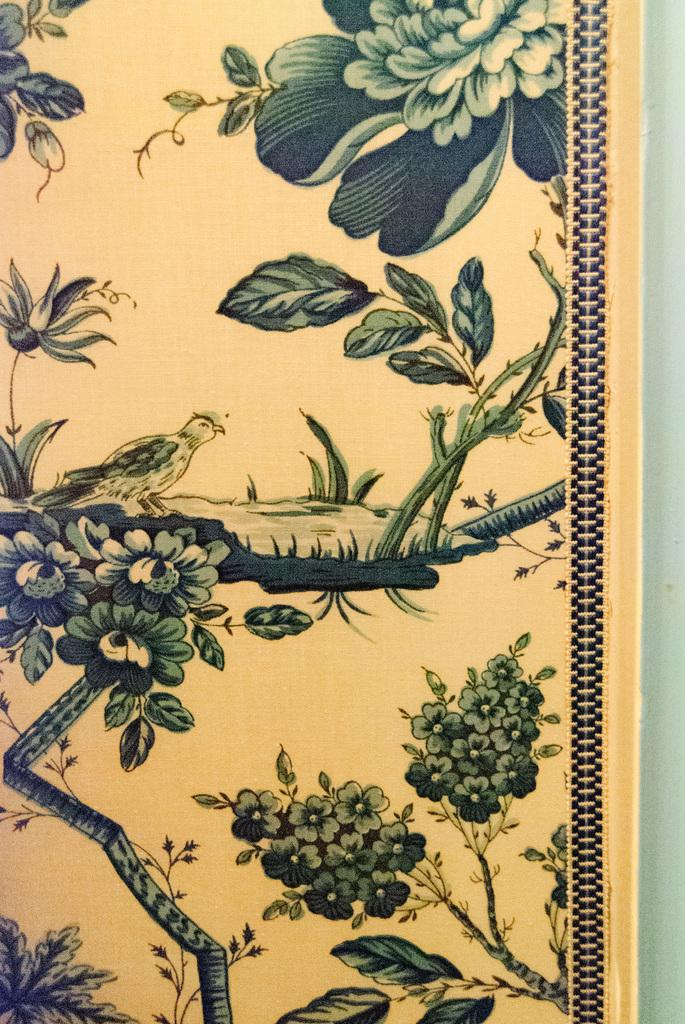What type of artwork is depicted in the image? The image is a painting. What can be seen in the painting? There is a bird on the tree in the painting, and there are flowers on the tree as well. What is the background of the painting? There appears to be a wall on the right side of the painting. What type of legal advice is the family seeking in the painting? There is no family or lawyer present in the painting, so it is not possible to determine any legal advice being sought. 